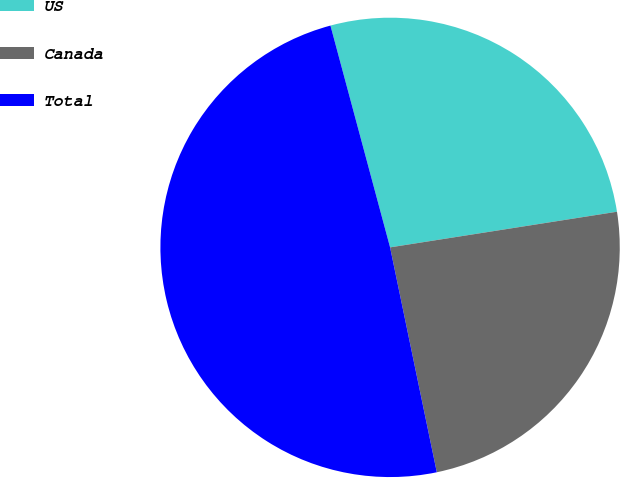Convert chart to OTSL. <chart><loc_0><loc_0><loc_500><loc_500><pie_chart><fcel>US<fcel>Canada<fcel>Total<nl><fcel>26.7%<fcel>24.22%<fcel>49.08%<nl></chart> 